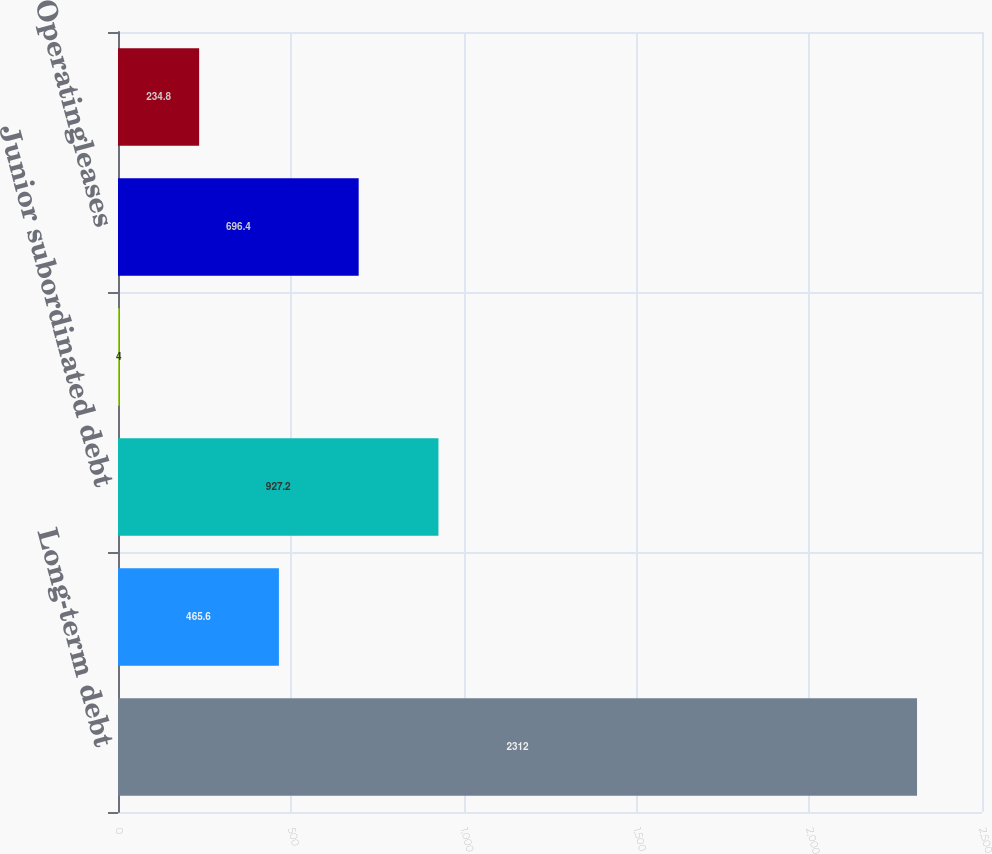<chart> <loc_0><loc_0><loc_500><loc_500><bar_chart><fcel>Long-term debt<fcel>Collateral financing<fcel>Junior subordinated debt<fcel>Commitmentstolendfunds<fcel>Operatingleases<fcel>Other<nl><fcel>2312<fcel>465.6<fcel>927.2<fcel>4<fcel>696.4<fcel>234.8<nl></chart> 